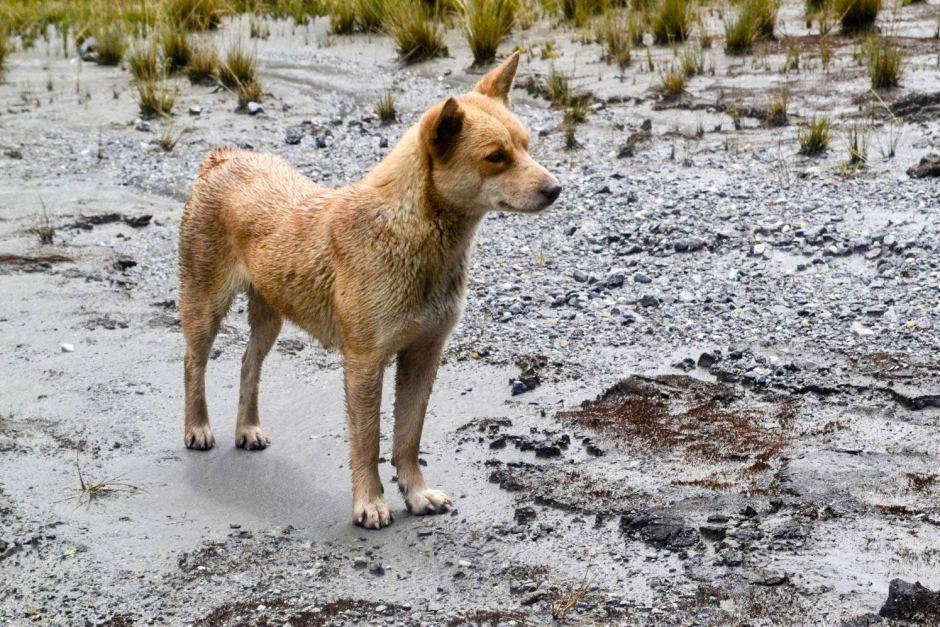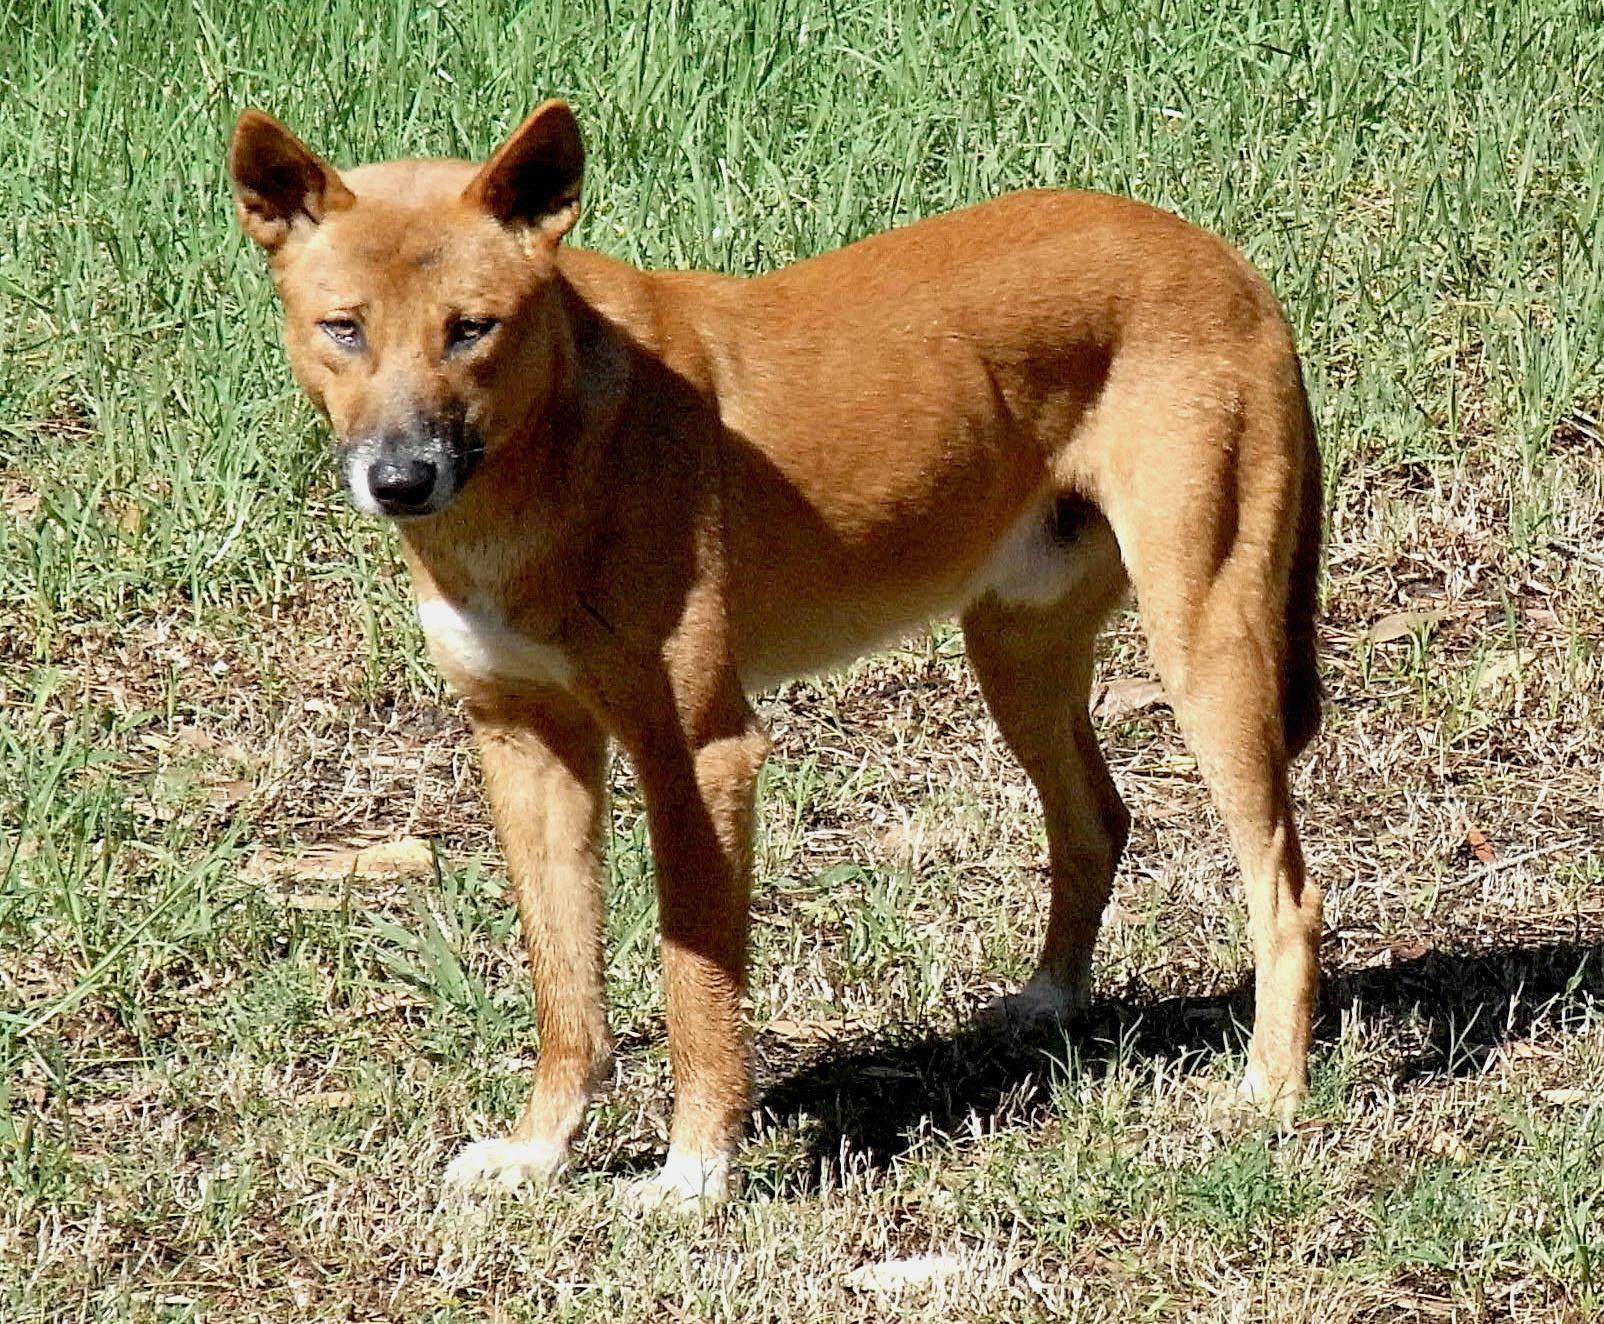The first image is the image on the left, the second image is the image on the right. Given the left and right images, does the statement "The dog in the right image is on a grassy surface." hold true? Answer yes or no. Yes. 